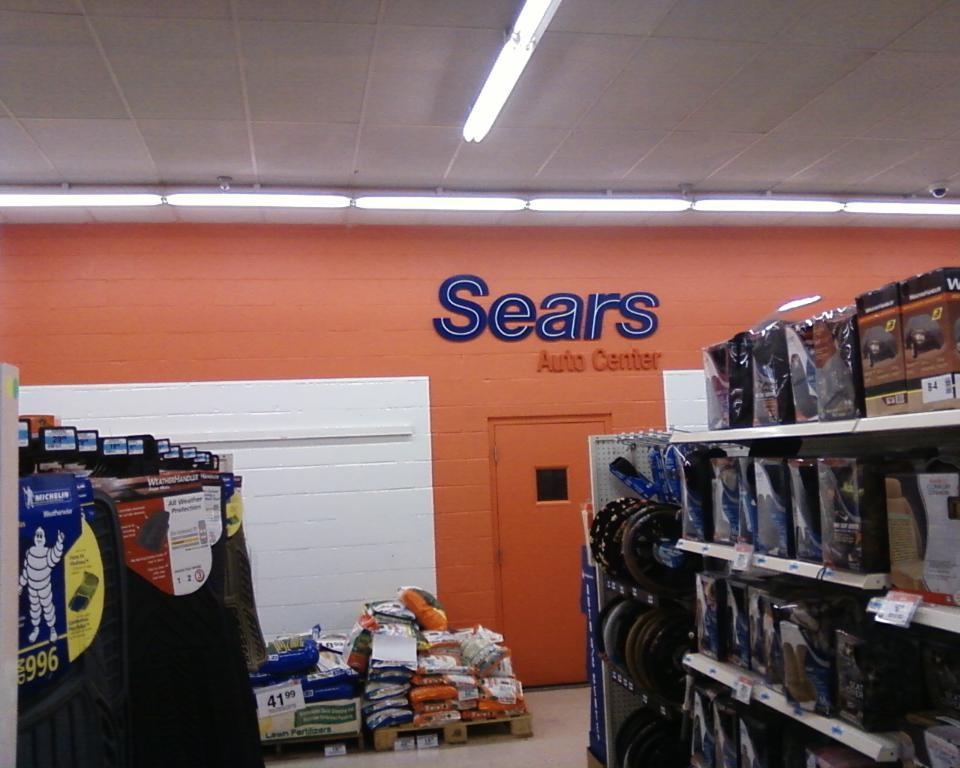Provide a one-sentence caption for the provided image. Automobile care and maintenance supplies are available at Sears. 